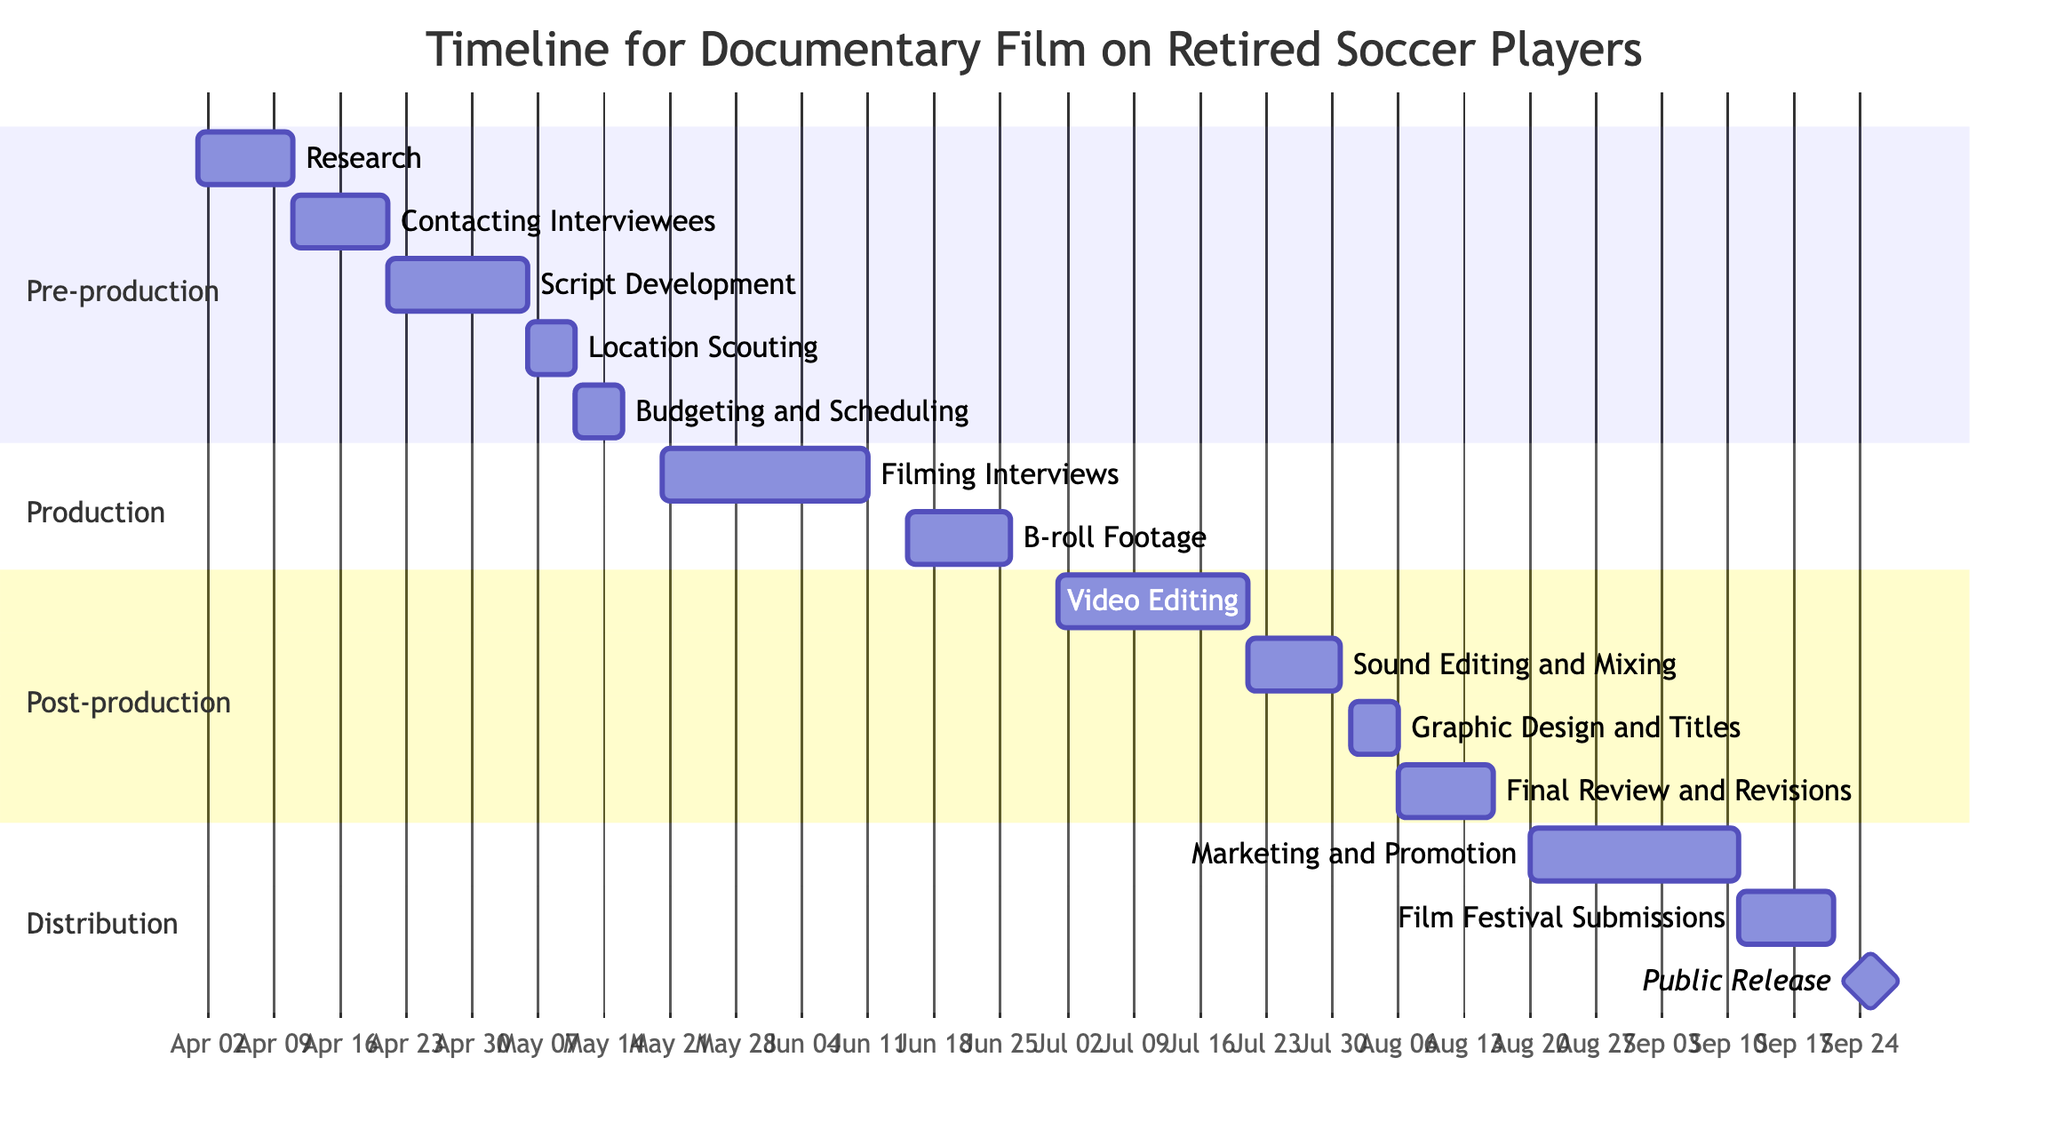What is the duration of the "Research" task? The "Research" task starts on April 1, 2023, and ends on April 10, 2023. The duration is calculated by counting the days from the start date to the end date, which is 10 days.
Answer: 10 days Which task follows "Location Scouting" in the Pre-production phase? In the Pre-production phase, "Location Scouting" ends on May 10, 2023. The next task listed is "Budgeting and Scheduling," which starts immediately after "Location Scouting" on May 11, 2023.
Answer: Budgeting and Scheduling When does the "Filming Interviews" task begin? The task "Filming Interviews" begins on May 20, 2023. This information is clear as it is marked as the start date in the Production phase.
Answer: May 20, 2023 How many tasks are in the Post-production phase? In the Post-production section, there are four tasks listed: "Video Editing," "Sound Editing and Mixing," "Graphic Design and Titles," and "Final Review and Revisions." Counting these, there are four tasks.
Answer: 4 What is the end date of the "Public Release" task? The "Public Release" task is marked as occurring on September 25, 2023, which is specified clearly as its end date.
Answer: September 25, 2023 Which task has the longest duration in the Production phase? In the Production phase, "Filming Interviews" spans from May 20, 2023, to June 10, 2023, lasting 22 days. "B-roll Footage" follows and lasts 11 days. Therefore, "Filming Interviews" has the longest duration.
Answer: Filming Interviews What is the immediate task after "Sound Editing and Mixing"? "Sound Editing and Mixing" ends on July 30, 2023, and the subsequent task that follows is "Graphic Design and Titles," which begins on August 1, 2023.
Answer: Graphic Design and Titles How many total phases are in the timeline? The diagram contains four distinct phases: Pre-production, Production, Post-production, and Distribution. Counting these, there are four phases total.
Answer: 4 What is the milestone date for the documentary film's public release? The milestone date for the public release of the documentary film is clearly indicated as September 25, 2023, with the milestone marker.
Answer: September 25, 2023 